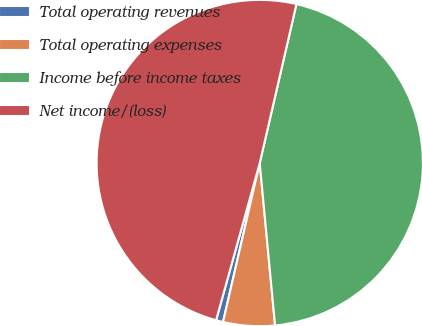<chart> <loc_0><loc_0><loc_500><loc_500><pie_chart><fcel>Total operating revenues<fcel>Total operating expenses<fcel>Income before income taxes<fcel>Net income/(loss)<nl><fcel>0.7%<fcel>5.11%<fcel>44.89%<fcel>49.3%<nl></chart> 